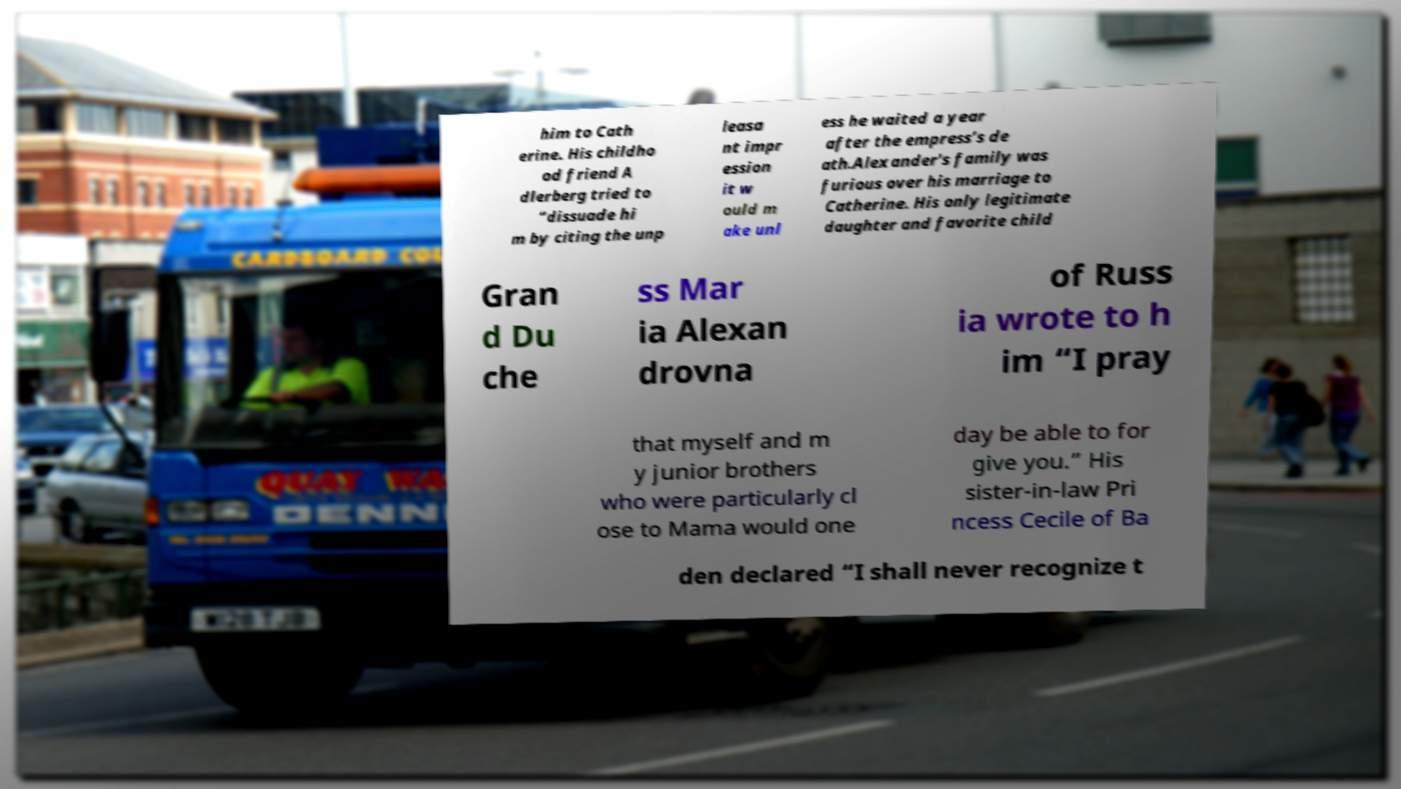What messages or text are displayed in this image? I need them in a readable, typed format. him to Cath erine. His childho od friend A dlerberg tried to “dissuade hi m by citing the unp leasa nt impr ession it w ould m ake unl ess he waited a year after the empress’s de ath.Alexander's family was furious over his marriage to Catherine. His only legitimate daughter and favorite child Gran d Du che ss Mar ia Alexan drovna of Russ ia wrote to h im “I pray that myself and m y junior brothers who were particularly cl ose to Mama would one day be able to for give you.” His sister-in-law Pri ncess Cecile of Ba den declared “I shall never recognize t 